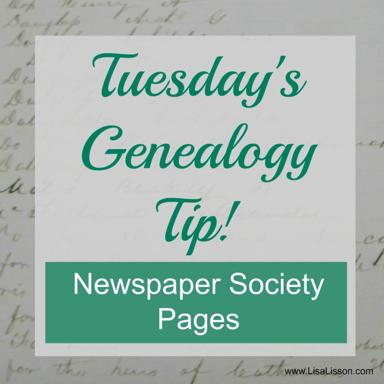What is the website mentioned in the image? The website mentioned in the image is www.LisaLisson.com. This site appears to be a resource for genealogical tips and information, emphasizing practical advice for tracing family histories. 